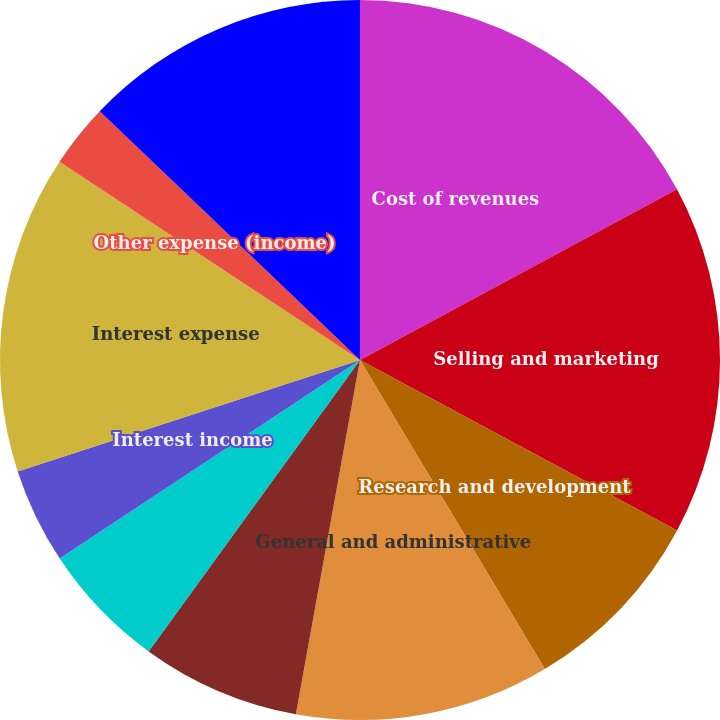Convert chart. <chart><loc_0><loc_0><loc_500><loc_500><pie_chart><fcel>Cost of revenues<fcel>Selling and marketing<fcel>Research and development<fcel>General and administrative<fcel>Amortization of intangible<fcel>Depreciation and amortization<fcel>Interest income<fcel>Interest expense<fcel>Other expense (income)<fcel>Other expense (income) net<nl><fcel>17.14%<fcel>15.71%<fcel>8.57%<fcel>11.43%<fcel>7.14%<fcel>5.71%<fcel>4.29%<fcel>14.29%<fcel>2.86%<fcel>12.86%<nl></chart> 